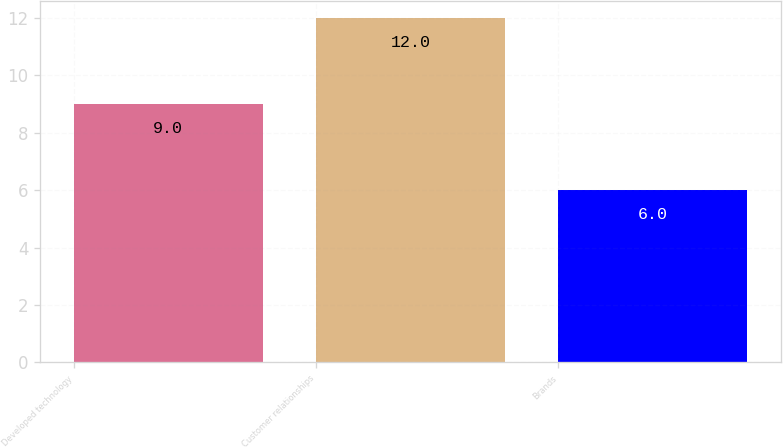<chart> <loc_0><loc_0><loc_500><loc_500><bar_chart><fcel>Developed technology<fcel>Customer relationships<fcel>Brands<nl><fcel>9<fcel>12<fcel>6<nl></chart> 